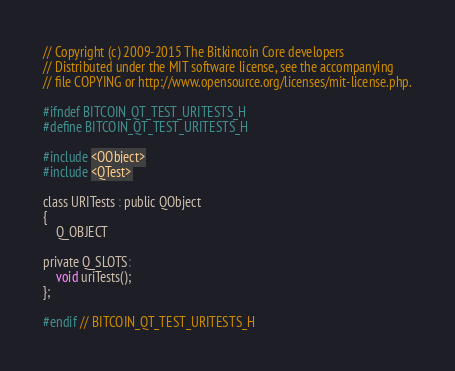<code> <loc_0><loc_0><loc_500><loc_500><_C_>// Copyright (c) 2009-2015 The Bitkincoin Core developers
// Distributed under the MIT software license, see the accompanying
// file COPYING or http://www.opensource.org/licenses/mit-license.php.

#ifndef BITCOIN_QT_TEST_URITESTS_H
#define BITCOIN_QT_TEST_URITESTS_H

#include <QObject>
#include <QTest>

class URITests : public QObject
{
    Q_OBJECT

private Q_SLOTS:
    void uriTests();
};

#endif // BITCOIN_QT_TEST_URITESTS_H
</code> 